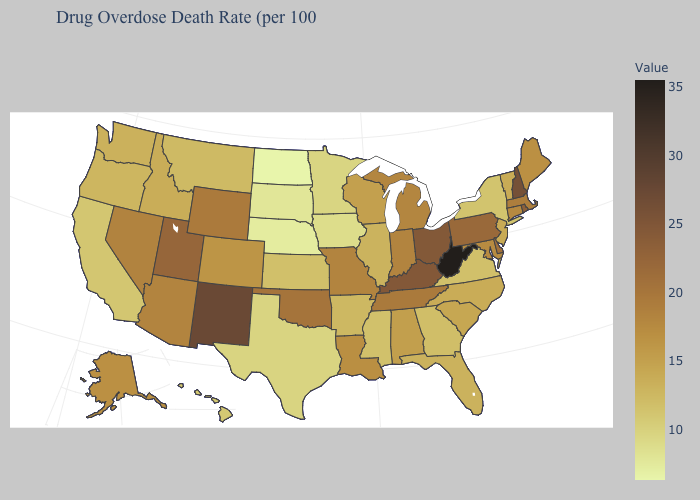Among the states that border Pennsylvania , which have the lowest value?
Concise answer only. New York. Does Hawaii have the lowest value in the West?
Keep it brief. Yes. Does Missouri have the highest value in the MidWest?
Short answer required. No. Does West Virginia have the highest value in the USA?
Write a very short answer. Yes. Which states hav the highest value in the West?
Write a very short answer. New Mexico. Which states have the lowest value in the West?
Be succinct. Hawaii. Does New Mexico have a lower value than South Carolina?
Answer briefly. No. Among the states that border Oklahoma , which have the lowest value?
Quick response, please. Texas. Does the map have missing data?
Be succinct. No. 